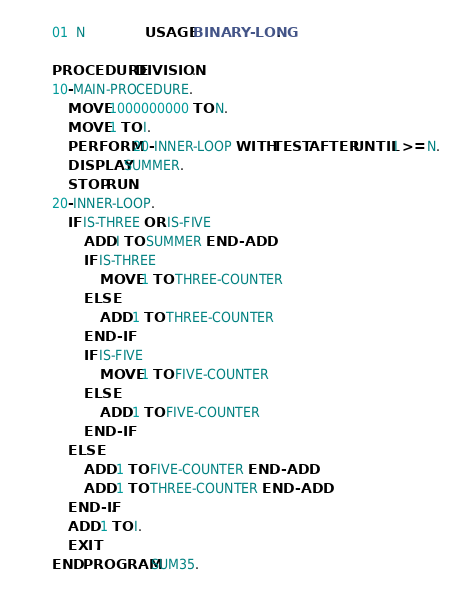<code> <loc_0><loc_0><loc_500><loc_500><_COBOL_>       01  N               USAGE BINARY-LONG.

       PROCEDURE DIVISION.
       10-MAIN-PROCEDURE.
           MOVE 1000000000 TO N.
           MOVE 1 TO I.
           PERFORM 20-INNER-LOOP WITH TEST AFTER UNTIL I >= N.
           DISPLAY SUMMER.
           STOP RUN.
       20-INNER-LOOP.
           IF IS-THREE OR IS-FIVE
               ADD I TO SUMMER END-ADD
               IF IS-THREE
                   MOVE 1 TO THREE-COUNTER
               ELSE
                   ADD 1 TO THREE-COUNTER
               END-IF
               IF IS-FIVE
                   MOVE 1 TO FIVE-COUNTER
               ELSE
                   ADD 1 TO FIVE-COUNTER
               END-IF
           ELSE
               ADD 1 TO FIVE-COUNTER END-ADD
               ADD 1 TO THREE-COUNTER END-ADD
           END-IF.
           ADD 1 TO I.
           EXIT.
       END PROGRAM SUM35.
</code> 